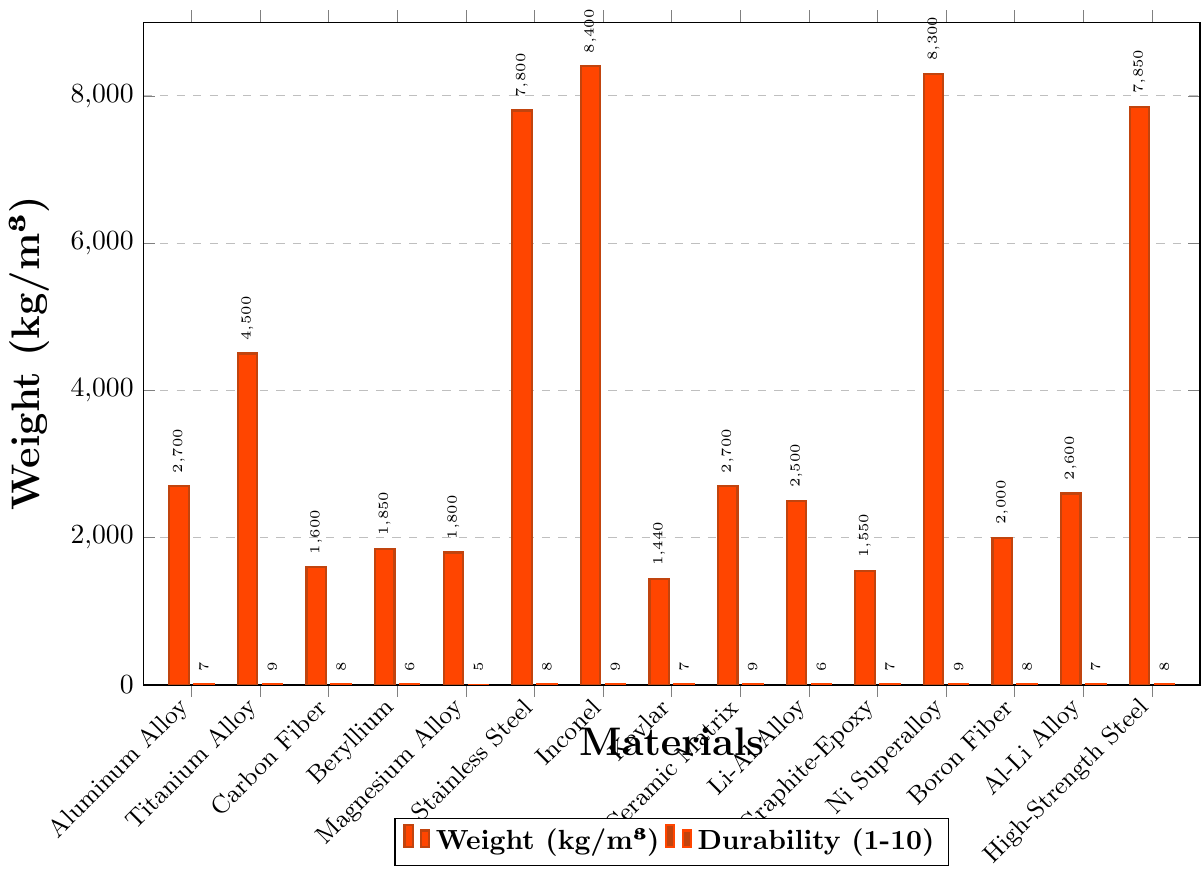Which material has the highest weight? From the figure, the tallest bar on the weight (kg/m³) axis represents the material with the highest weight, which is Inconel.
Answer: Inconel Which materials have a durability rating of 9? By looking at the durability bars at the "9" mark along the respective materials, these are Titanium Alloy, Inconel, Ceramic Matrix Composite, Nickel-Based Superalloy.
Answer: Titanium Alloy, Inconel, Ceramic Matrix Composite, Nickel-Based Superalloy Which material has the lowest weight and what is its corresponding durability? The shortest bar on the weight axis represents the material with the lowest weight, which is Kevlar. The corresponding durability for Kevlar is visible in its paired bar, indicating a durability of 7.
Answer: Kevlar, 7 How much heavier is Stainless Steel compared to Magnesium Alloy? Locate the bars for Stainless Steel and Magnesium Alloy on the weight (kg/m³) axis. Stainless Steel has a weight of 7800 kg/m³, and Magnesium Alloy has a weight of 1800 kg/m³. The difference is 7800 - 1800 = 6000 kg/m³.
Answer: 6000 kg/m³ What is the average durability rating of all materials? To find the average durability rating, sum up the durability values of all materials and divide by the number of materials. The durabilities are: 7, 9, 8, 6, 5, 8, 9, 7, 9, 6, 7, 9, 8, 7, 8. Summing these gives 113. There are 15 materials, so the average is 113/15.
Answer: 7.53 Which material has the smallest difference between its weight and durability? Calculate the difference between weight and durability for each material and find the smallest value. Considering the significant difference in the units, normalizing the data before calculation would be helpful. However, this is just conceptual in this context. For a simple calculation: Aluminum Alloy (2693), Titanium Alloy (4491), Carbon Fiber Composite (1592), Beryllium (1844), Magnesium Alloy (1795), Stainless Steel (7792), Inconel (8391), Kevlar (1433), Ceramic Matrix Composite (2691), Lithium-Aluminum Alloy (2494), Graphite-Epoxy Composite (1543), Nickel-Based Superalloy (8291), Boron Fiber Composite (1992), Aluminum-Lithium Alloy (2593), High-Strength Steel (7842). The smallest difference appears to be with Kevlar.
Answer: Kevlar 